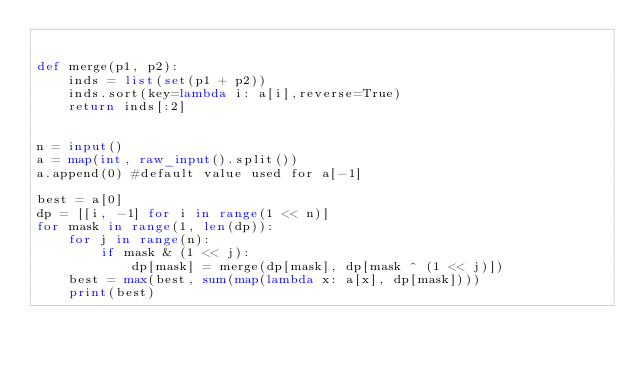Convert code to text. <code><loc_0><loc_0><loc_500><loc_500><_Python_>

def merge(p1, p2):
    inds = list(set(p1 + p2))
    inds.sort(key=lambda i: a[i],reverse=True)
    return inds[:2]


n = input()
a = map(int, raw_input().split())
a.append(0) #default value used for a[-1]

best = a[0]
dp = [[i, -1] for i in range(1 << n)]
for mask in range(1, len(dp)):
    for j in range(n):
        if mask & (1 << j):
            dp[mask] = merge(dp[mask], dp[mask ^ (1 << j)])
    best = max(best, sum(map(lambda x: a[x], dp[mask])))
    print(best)
</code> 